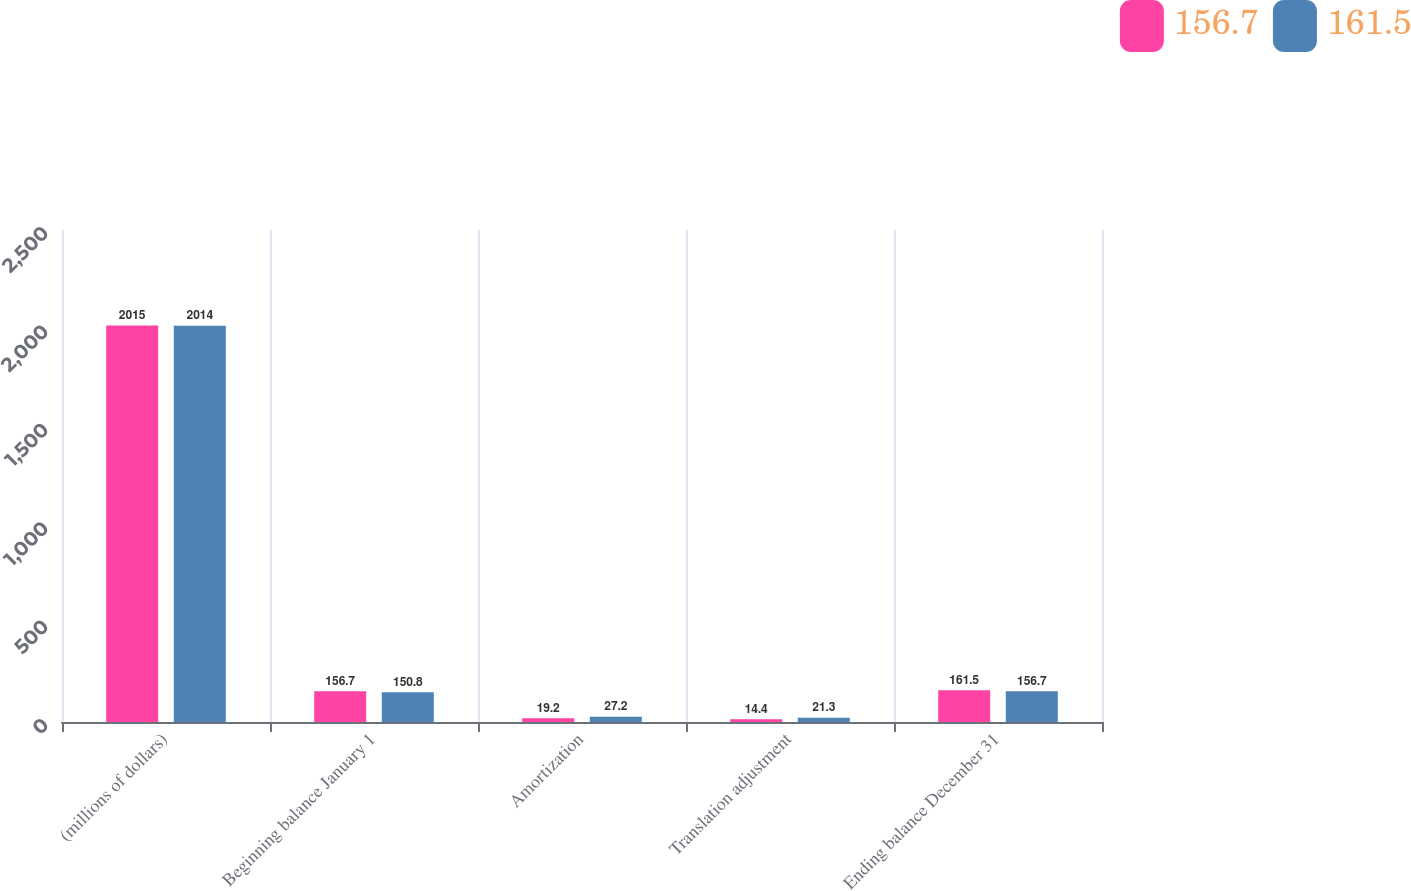Convert chart. <chart><loc_0><loc_0><loc_500><loc_500><stacked_bar_chart><ecel><fcel>(millions of dollars)<fcel>Beginning balance January 1<fcel>Amortization<fcel>Translation adjustment<fcel>Ending balance December 31<nl><fcel>156.7<fcel>2015<fcel>156.7<fcel>19.2<fcel>14.4<fcel>161.5<nl><fcel>161.5<fcel>2014<fcel>150.8<fcel>27.2<fcel>21.3<fcel>156.7<nl></chart> 